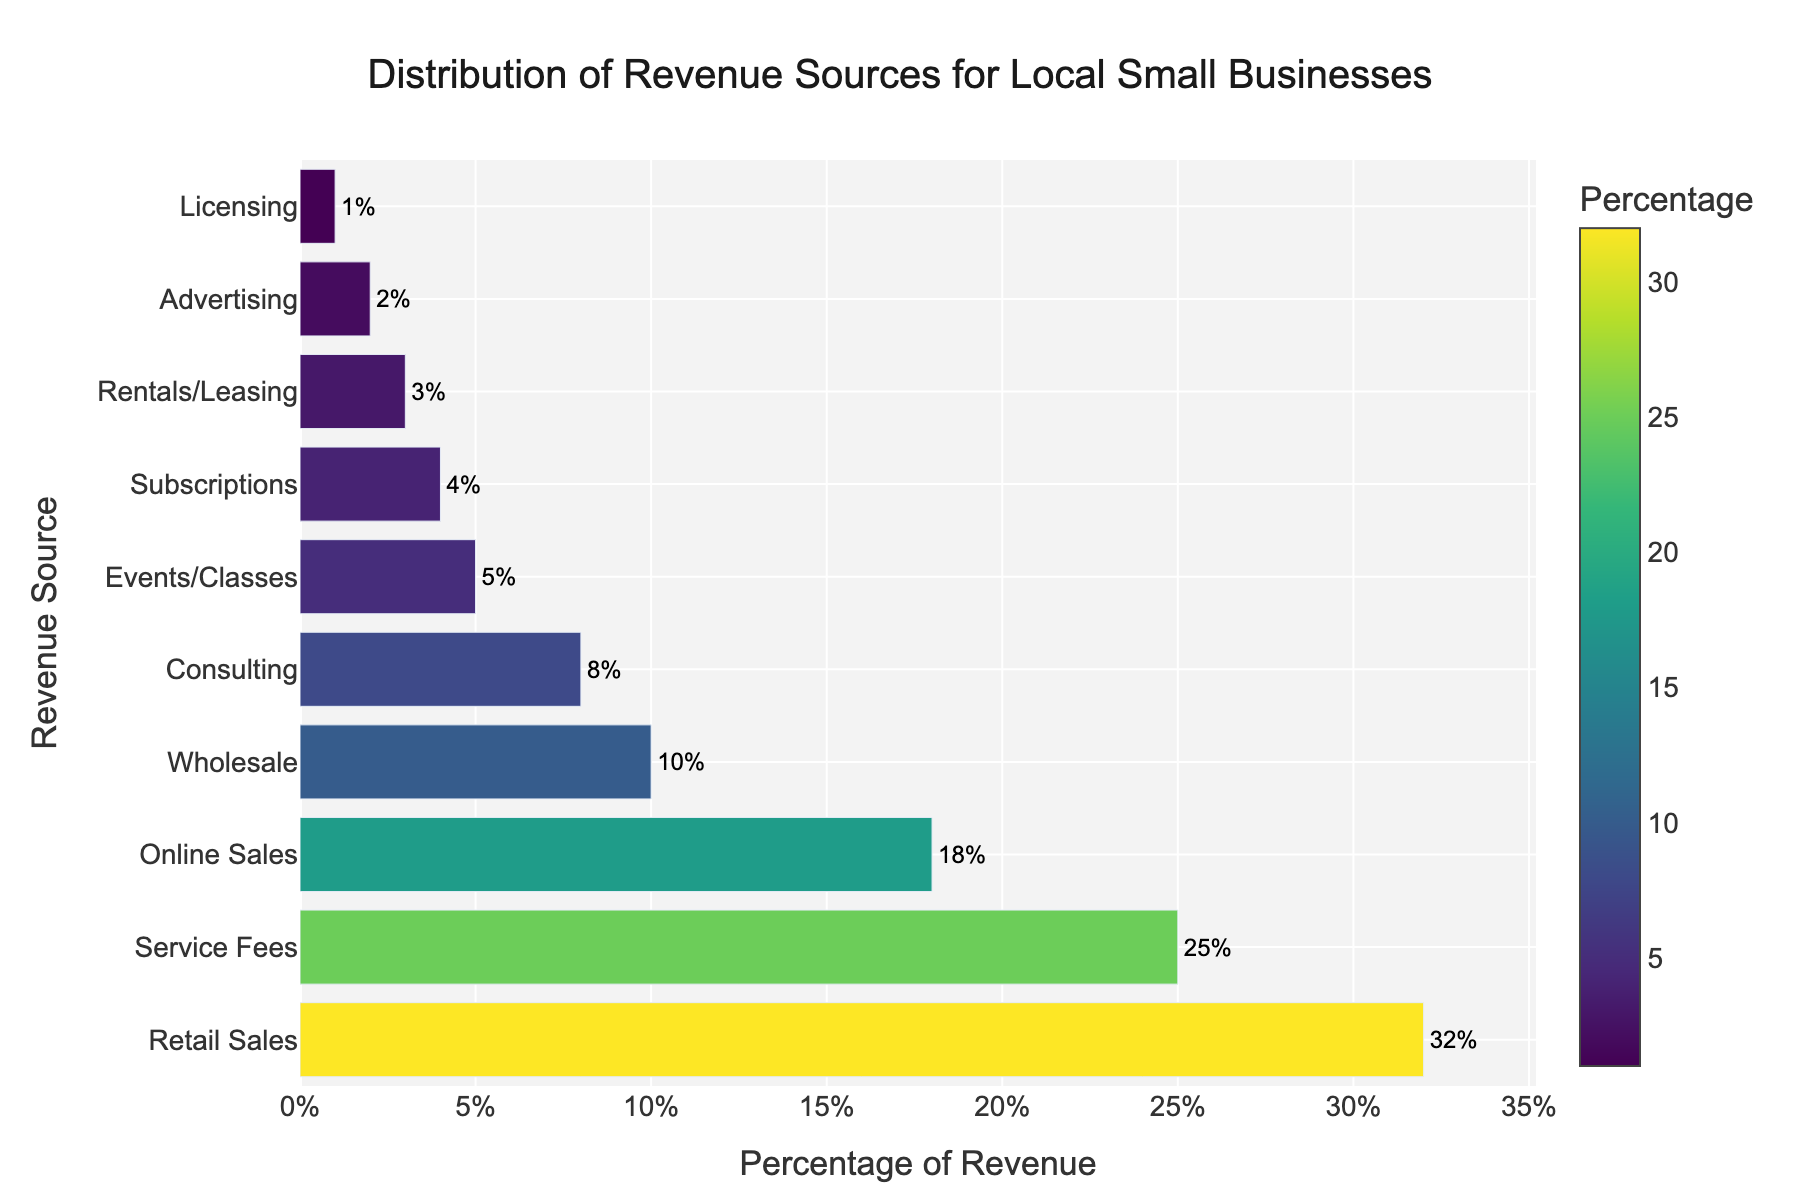What is the percentage of revenue from Retail Sales? The bar chart shows that the percentage of revenue from Retail Sales is labeled as 32% at the top of the chart.
Answer: 32% Which revenue source generates the least percentage of revenue? The bar chart indicates that Licensing, at the bottom, has the smallest percentage of revenue at 1%.
Answer: Licensing Is the percentage of revenue from Service Fees greater than Online Sales? The bar chart shows that Service Fees have a percentage of 25%, while Online Sales have 18%. Therefore, Service Fees are greater.
Answer: Yes What is the combined percentage of revenue from Subscriptions and Rentals/Leasing? The bar chart displays Subscriptions at 4% and Rentals/Leasing at 3%. Adding these together, we get 4% + 3% = 7%.
Answer: 7% How much more revenue, percentage-wise, do Retail Sales generate compared to Events/Classes? Retail Sales generate 32% and Events/Classes generate 5%. The difference is 32% - 5% = 27%.
Answer: 27% Which revenue source contributes just below 10% to the total revenue? The bar chart indicates that Consulting, which is visually placed just below the 10% Wholesale bar, contributes 8%.
Answer: Consulting How many revenue sources contribute less than 5% each to the total revenue? According to the bar chart, Subscriptions (4%), Rentals/Leasing (3%), Advertising (2%), and Licensing (1%) each contribute less than 5%. Counting these, we get 4 sources.
Answer: 4 Which generates a higher percentage of revenue: Wholesale or Events/Classes? The bar chart shows Wholesale at 10% and Events/Classes at 5%. Therefore, Wholesale generates a higher percentage of revenue.
Answer: Wholesale What percentage of revenue is generated by sources contributing 3% or less? From the bar chart, Rentals/Leasing (3%), Advertising (2%), and Licensing (1%) are the sources, adding up to 3% + 2% + 1% = 6%.
Answer: 6% What is the percentage difference between the highest and lowest revenue sources? The highest revenue source, Retail Sales, has 32%, and the lowest, Licensing, has 1%. The percentage difference is 32% - 1% = 31%.
Answer: 31% 